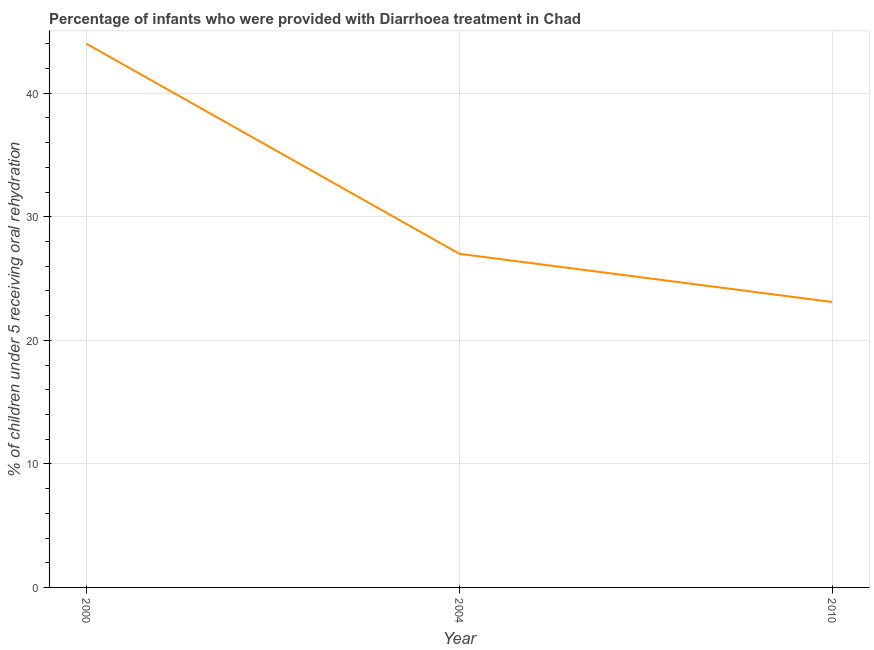What is the percentage of children who were provided with treatment diarrhoea in 2010?
Keep it short and to the point. 23.1. Across all years, what is the minimum percentage of children who were provided with treatment diarrhoea?
Ensure brevity in your answer.  23.1. In which year was the percentage of children who were provided with treatment diarrhoea maximum?
Your answer should be compact. 2000. What is the sum of the percentage of children who were provided with treatment diarrhoea?
Give a very brief answer. 94.1. What is the difference between the percentage of children who were provided with treatment diarrhoea in 2000 and 2010?
Your answer should be compact. 20.9. What is the average percentage of children who were provided with treatment diarrhoea per year?
Offer a very short reply. 31.37. What is the median percentage of children who were provided with treatment diarrhoea?
Make the answer very short. 27. What is the ratio of the percentage of children who were provided with treatment diarrhoea in 2000 to that in 2010?
Make the answer very short. 1.9. Is the percentage of children who were provided with treatment diarrhoea in 2000 less than that in 2004?
Your response must be concise. No. What is the difference between the highest and the second highest percentage of children who were provided with treatment diarrhoea?
Make the answer very short. 17. What is the difference between the highest and the lowest percentage of children who were provided with treatment diarrhoea?
Offer a very short reply. 20.9. In how many years, is the percentage of children who were provided with treatment diarrhoea greater than the average percentage of children who were provided with treatment diarrhoea taken over all years?
Your answer should be compact. 1. Does the percentage of children who were provided with treatment diarrhoea monotonically increase over the years?
Give a very brief answer. No. What is the difference between two consecutive major ticks on the Y-axis?
Ensure brevity in your answer.  10. What is the title of the graph?
Make the answer very short. Percentage of infants who were provided with Diarrhoea treatment in Chad. What is the label or title of the X-axis?
Your answer should be compact. Year. What is the label or title of the Y-axis?
Ensure brevity in your answer.  % of children under 5 receiving oral rehydration. What is the % of children under 5 receiving oral rehydration in 2004?
Offer a very short reply. 27. What is the % of children under 5 receiving oral rehydration of 2010?
Provide a short and direct response. 23.1. What is the difference between the % of children under 5 receiving oral rehydration in 2000 and 2010?
Offer a very short reply. 20.9. What is the difference between the % of children under 5 receiving oral rehydration in 2004 and 2010?
Offer a terse response. 3.9. What is the ratio of the % of children under 5 receiving oral rehydration in 2000 to that in 2004?
Provide a succinct answer. 1.63. What is the ratio of the % of children under 5 receiving oral rehydration in 2000 to that in 2010?
Offer a very short reply. 1.91. What is the ratio of the % of children under 5 receiving oral rehydration in 2004 to that in 2010?
Provide a succinct answer. 1.17. 